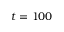Convert formula to latex. <formula><loc_0><loc_0><loc_500><loc_500>t = 1 0 0</formula> 